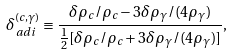Convert formula to latex. <formula><loc_0><loc_0><loc_500><loc_500>\delta ^ { ( c , \gamma ) } _ { a d i } \equiv \frac { \delta \rho _ { c } / \rho _ { c } - 3 \delta \rho _ { \gamma } / ( 4 \rho _ { \gamma } ) } { \frac { 1 } { 2 } [ \delta \rho _ { c } / \rho _ { c } + 3 \delta \rho _ { \gamma } / ( 4 \rho _ { \gamma } ) ] } ,</formula> 